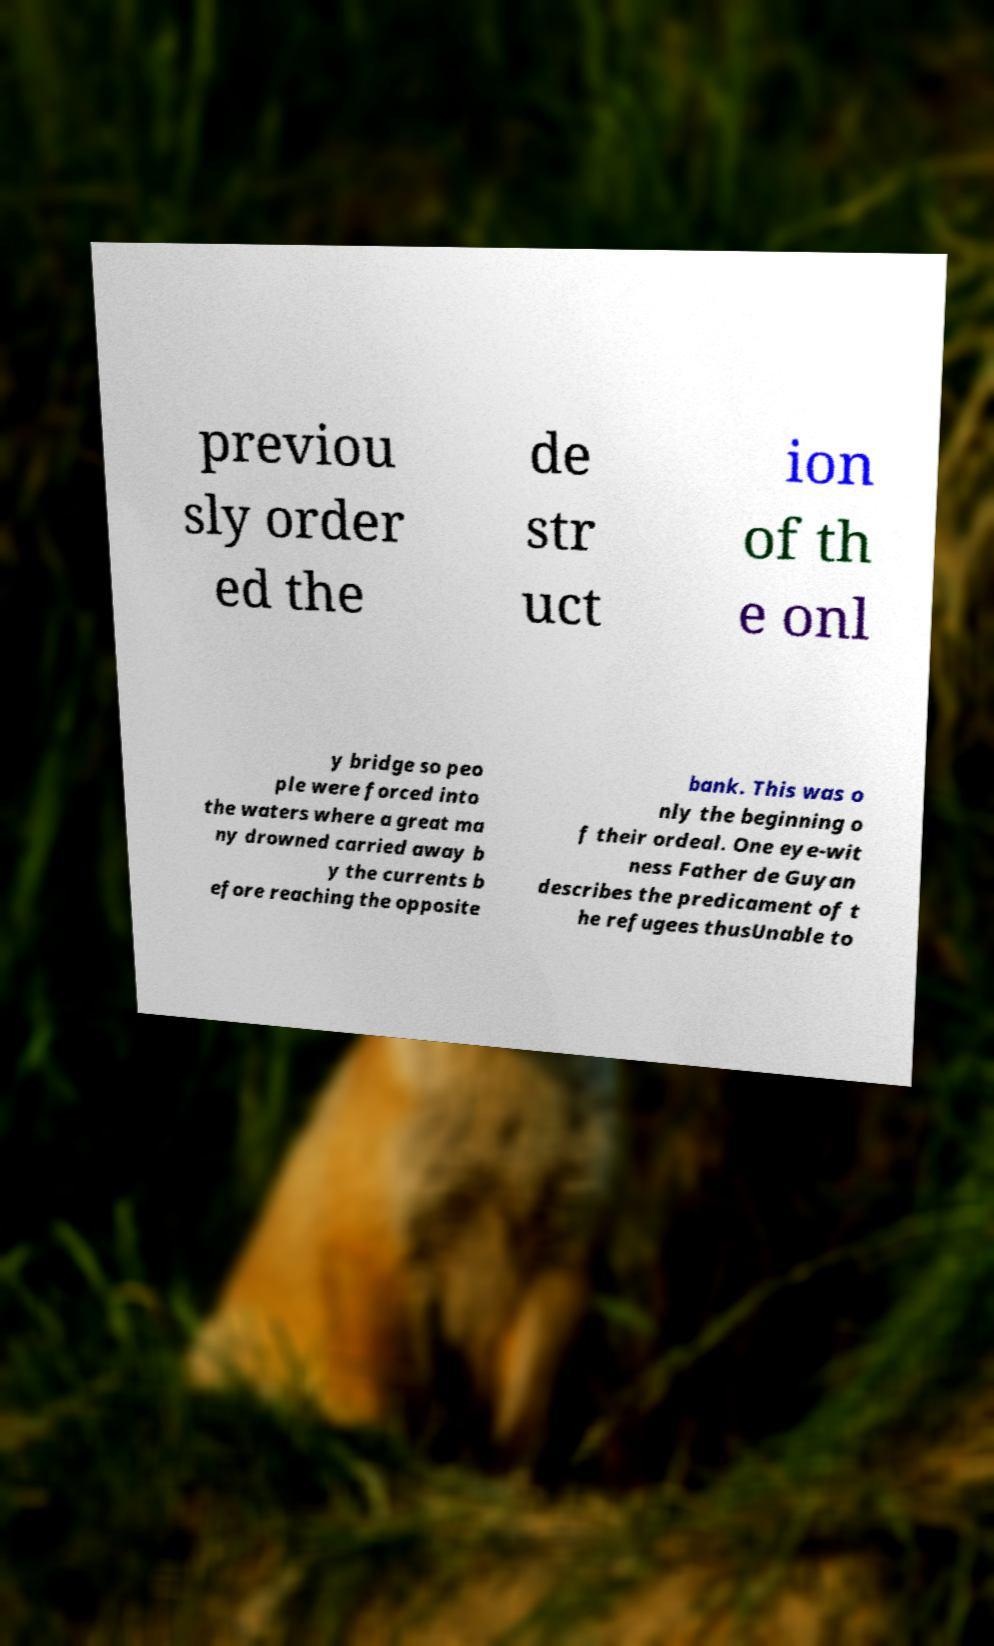Can you accurately transcribe the text from the provided image for me? previou sly order ed the de str uct ion of th e onl y bridge so peo ple were forced into the waters where a great ma ny drowned carried away b y the currents b efore reaching the opposite bank. This was o nly the beginning o f their ordeal. One eye-wit ness Father de Guyan describes the predicament of t he refugees thusUnable to 